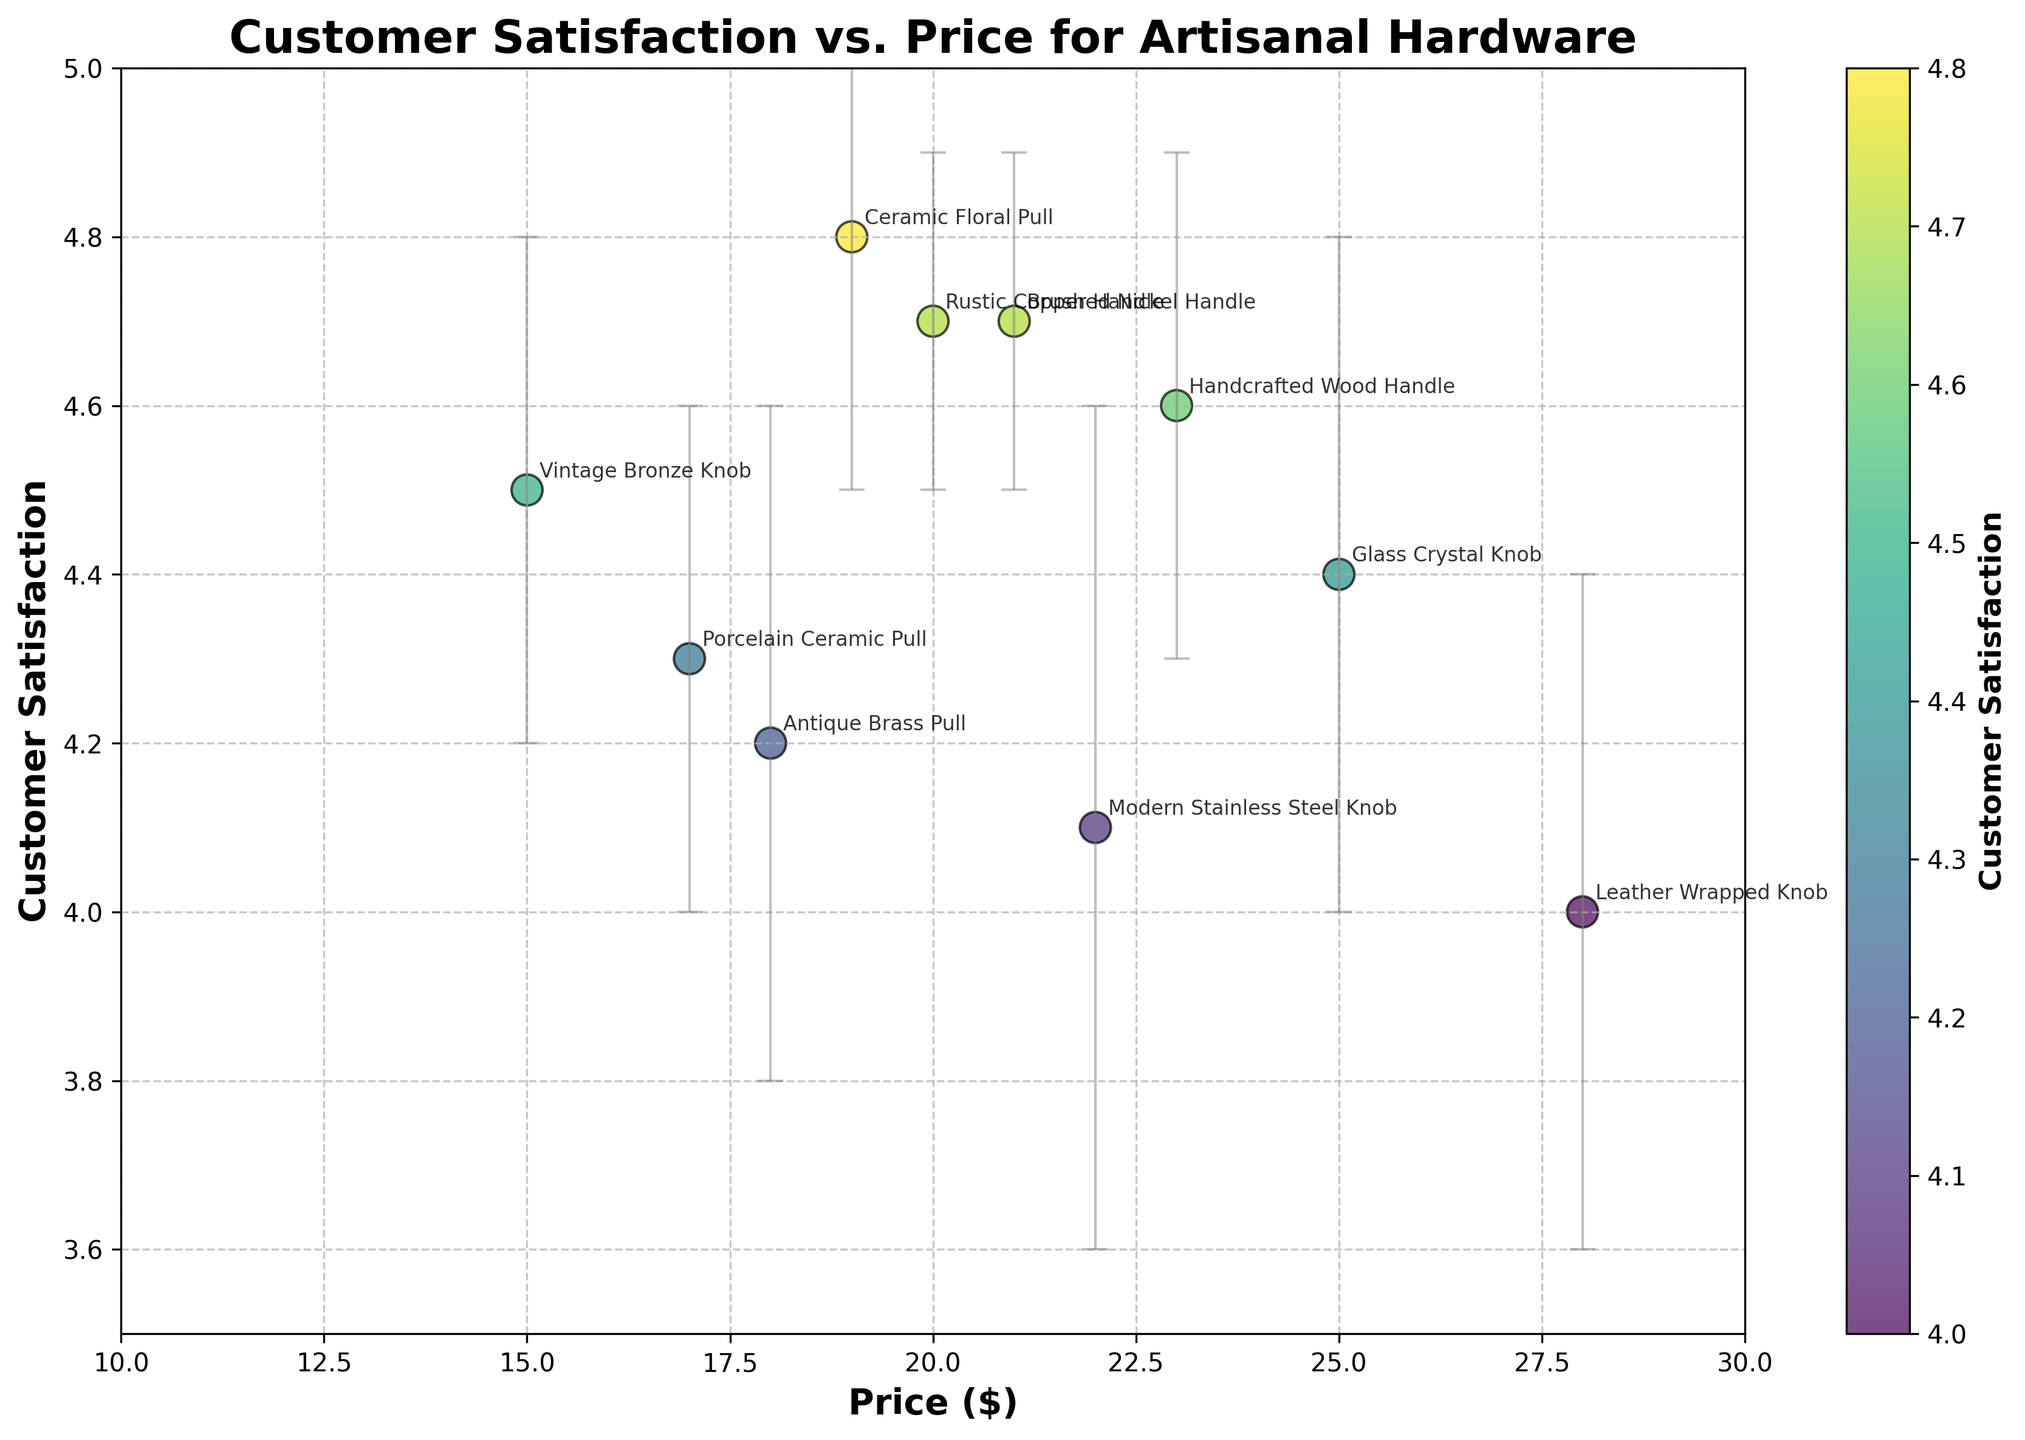What is the title of the scatter plot? The title of the scatter plot is located at the top of the figure. It reads "Customer Satisfaction vs. Price for Artisanal Hardware."
Answer: Customer Satisfaction vs. Price for Artisanal Hardware How many products are displayed in the scatter plot? By counting the number of data points shown in the scatter plot, we observe there are 10 data points, each representing a different product.
Answer: 10 Which product has the highest customer satisfaction? By looking at the y-axis values and their corresponding labels, we can see that the Ceramic Floral Pull has the highest customer satisfaction of 4.8.
Answer: Ceramic Floral Pull What is the price range of the products shown in the plot? Observing the x-axis values from the scatter plot, we note that the prices range from $15 to $28.
Answer: $15 to $28 Which product shows the highest variability in customer satisfaction? The error bars indicate variability. The Modern Stainless Steel Knob has the highest standard deviation at 0.5, indicating the most variability in customer satisfaction.
Answer: Modern Stainless Steel Knob What is the price and customer satisfaction of the Brushed Nickel Handle? By finding the Brushed Nickel Handle label on the plot, we observe that its price is $21 and customer satisfaction is 4.7.
Answer: $21, 4.7 How does the customer satisfaction of the Leather Wrapped Knob compare to the Glass Crystal Knob? The Leather Wrapped Knob has a customer satisfaction of 4.0, while the Glass Crystal Knob has 4.4, indicating that the Glass Crystal Knob has higher customer satisfaction.
Answer: Glass Crystal Knob has higher satisfaction Which product has a price closest to $20, and what is its customer satisfaction? The Rustic Copper Handle has a price of $20 and a customer satisfaction of 4.7.
Answer: Rustic Copper Handle, 4.7 Are there any products priced above $25? If yes, name them and provide their customer satisfaction. The Leather Wrapped Knob is priced at $28, and its customer satisfaction is 4.0. Additionally, the Glass Crystal Knob is priced at $25 with a satisfaction of 4.4.
Answer: Leather Wrapped Knob, 4.0 and Glass Crystal Knob, 4.4 Which product has a price of $22, and what is its standard deviation in customer satisfaction? The Modern Stainless Steel Knob is priced at $22, and its standard deviation in customer satisfaction is 0.5.
Answer: Modern Stainless Steel Knob, 0.5 